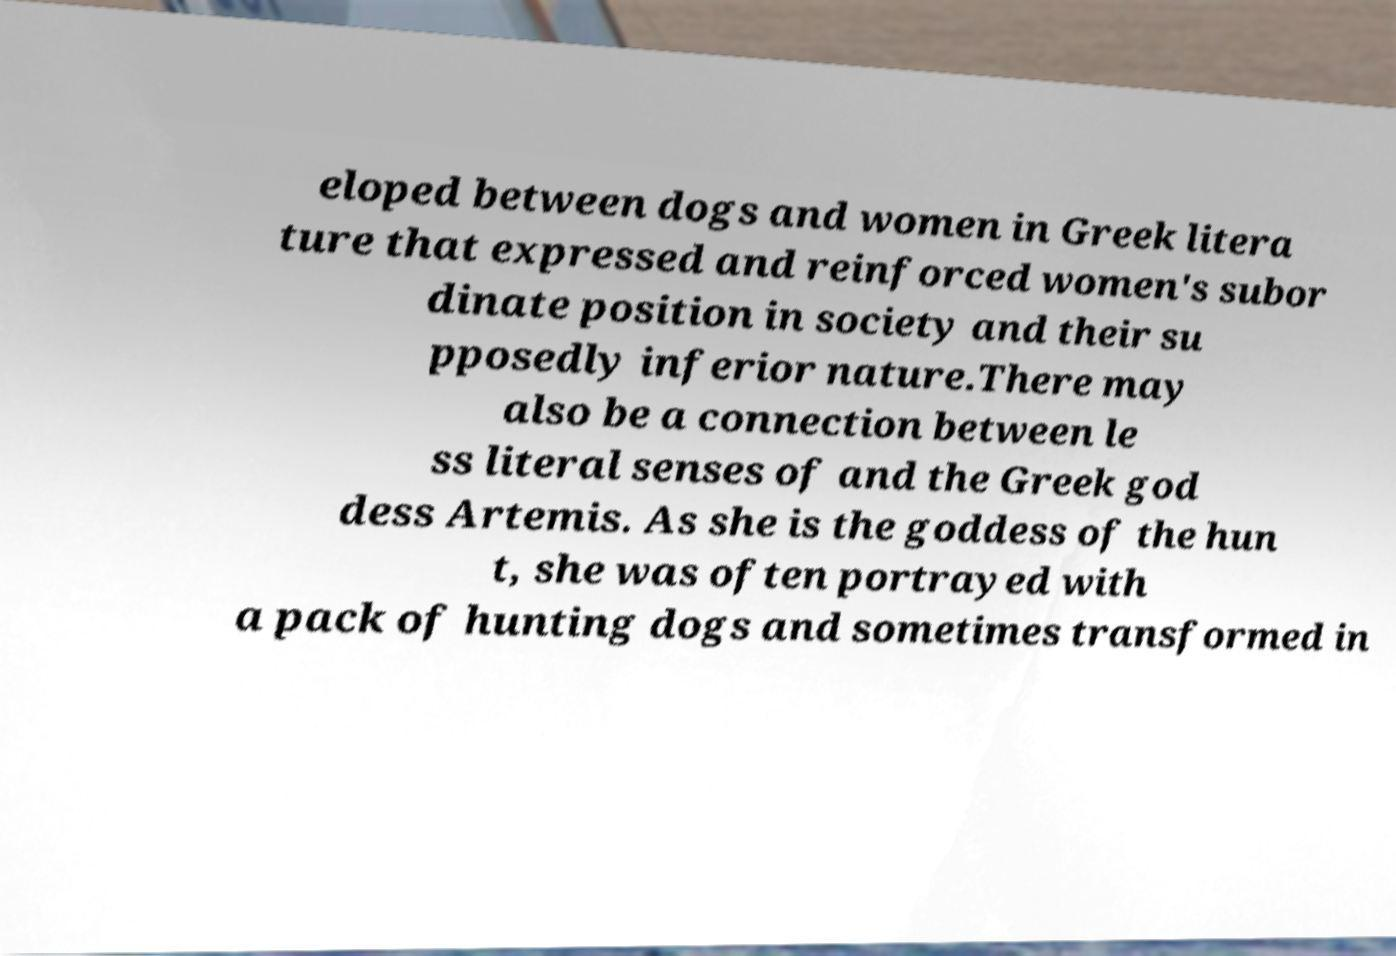For documentation purposes, I need the text within this image transcribed. Could you provide that? eloped between dogs and women in Greek litera ture that expressed and reinforced women's subor dinate position in society and their su pposedly inferior nature.There may also be a connection between le ss literal senses of and the Greek god dess Artemis. As she is the goddess of the hun t, she was often portrayed with a pack of hunting dogs and sometimes transformed in 